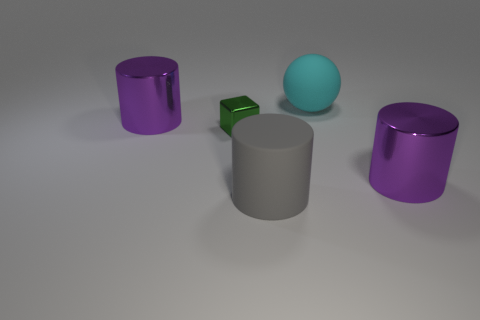Subtract all big gray cylinders. How many cylinders are left? 2 Add 2 large blue cylinders. How many objects exist? 7 Subtract all cyan cubes. How many purple cylinders are left? 2 Subtract all gray cylinders. How many cylinders are left? 2 Subtract 1 cylinders. How many cylinders are left? 2 Add 5 gray cylinders. How many gray cylinders are left? 6 Add 4 balls. How many balls exist? 5 Subtract 0 brown cylinders. How many objects are left? 5 Subtract all blocks. How many objects are left? 4 Subtract all red cylinders. Subtract all cyan spheres. How many cylinders are left? 3 